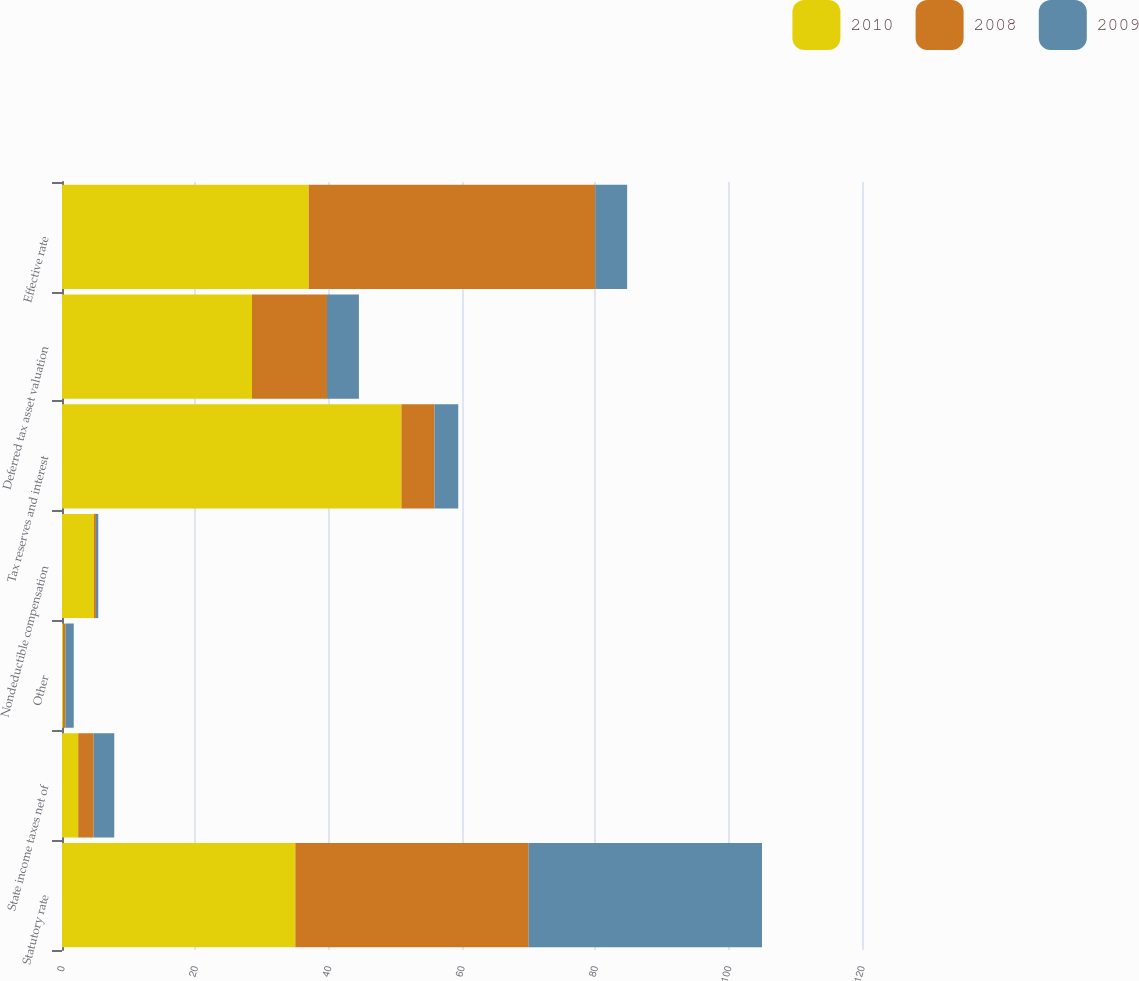<chart> <loc_0><loc_0><loc_500><loc_500><stacked_bar_chart><ecel><fcel>Statutory rate<fcel>State income taxes net of<fcel>Other<fcel>Nondeductible compensation<fcel>Tax reserves and interest<fcel>Deferred tax asset valuation<fcel>Effective rate<nl><fcel>2010<fcel>35<fcel>2.43<fcel>0.18<fcel>4.79<fcel>50.91<fcel>28.5<fcel>37.01<nl><fcel>2008<fcel>35<fcel>2.32<fcel>0.33<fcel>0.3<fcel>4.97<fcel>11.25<fcel>42.97<nl><fcel>2009<fcel>35<fcel>3.09<fcel>1.25<fcel>0.35<fcel>3.56<fcel>4.79<fcel>4.79<nl></chart> 